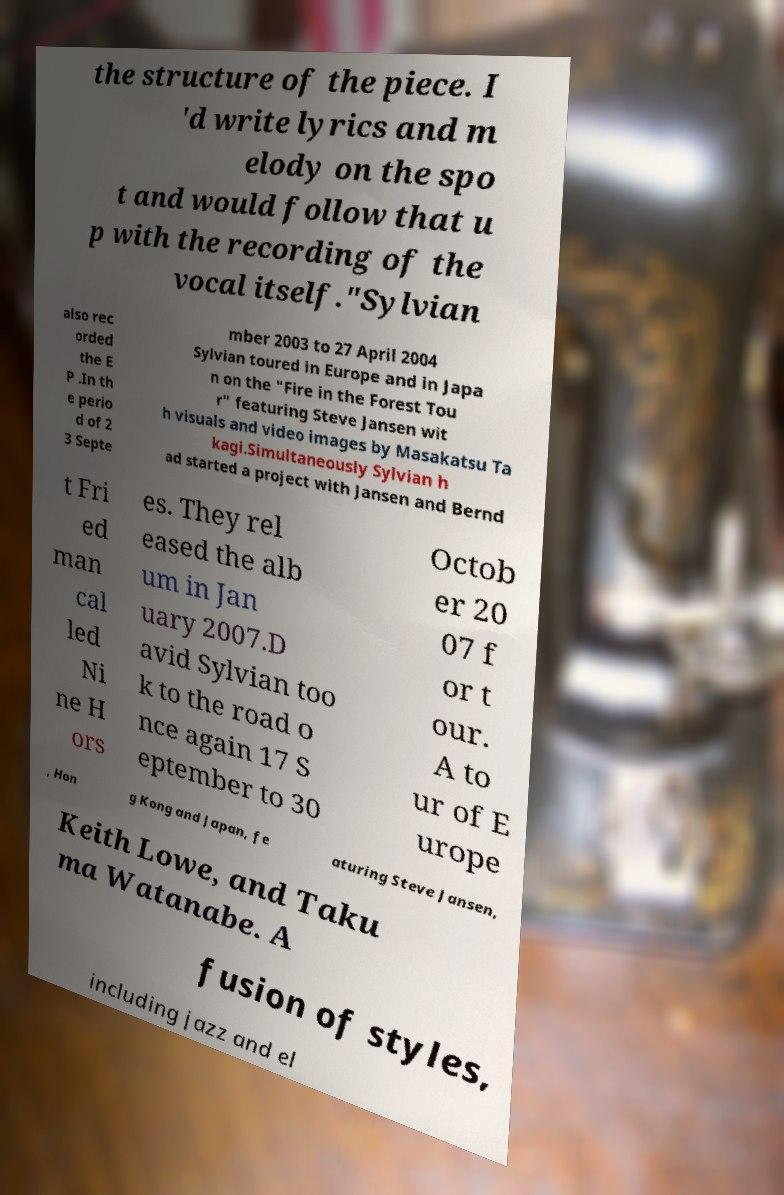Please identify and transcribe the text found in this image. the structure of the piece. I 'd write lyrics and m elody on the spo t and would follow that u p with the recording of the vocal itself."Sylvian also rec orded the E P .In th e perio d of 2 3 Septe mber 2003 to 27 April 2004 Sylvian toured in Europe and in Japa n on the "Fire in the Forest Tou r" featuring Steve Jansen wit h visuals and video images by Masakatsu Ta kagi.Simultaneously Sylvian h ad started a project with Jansen and Bernd t Fri ed man cal led Ni ne H ors es. They rel eased the alb um in Jan uary 2007.D avid Sylvian too k to the road o nce again 17 S eptember to 30 Octob er 20 07 f or t our. A to ur of E urope , Hon g Kong and Japan, fe aturing Steve Jansen, Keith Lowe, and Taku ma Watanabe. A fusion of styles, including jazz and el 